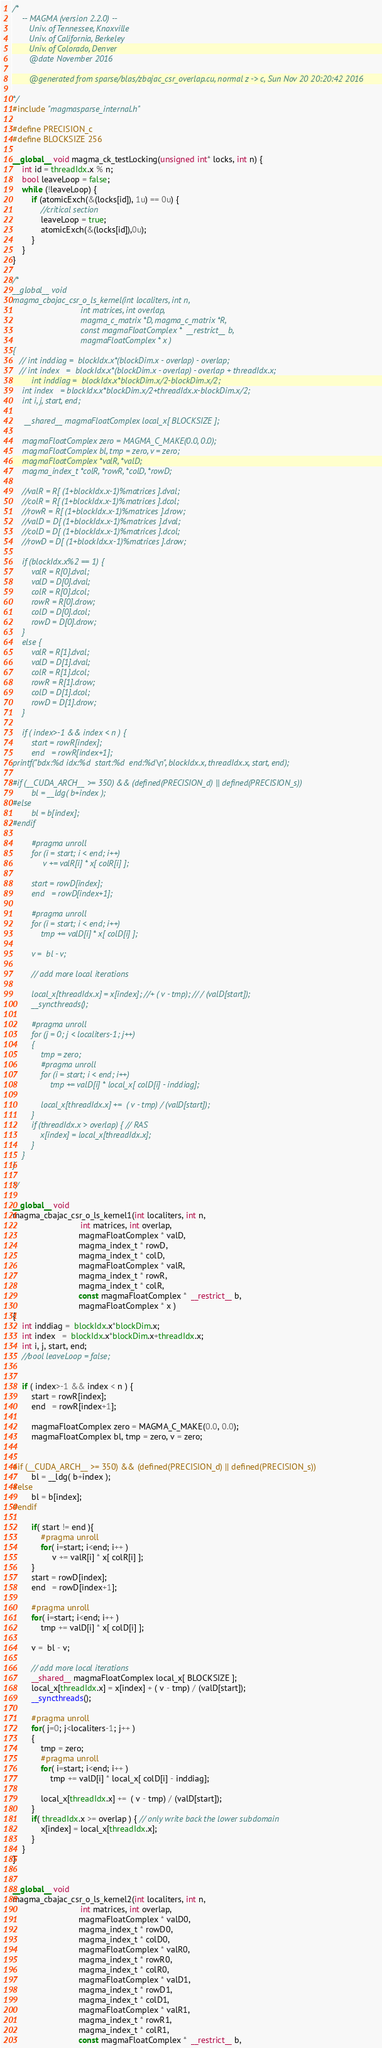<code> <loc_0><loc_0><loc_500><loc_500><_Cuda_>/*
    -- MAGMA (version 2.2.0) --
       Univ. of Tennessee, Knoxville
       Univ. of California, Berkeley
       Univ. of Colorado, Denver
       @date November 2016

       @generated from sparse/blas/zbajac_csr_overlap.cu, normal z -> c, Sun Nov 20 20:20:42 2016

*/
#include "magmasparse_internal.h"

#define PRECISION_c
#define BLOCKSIZE 256

__global__ void magma_ck_testLocking(unsigned int* locks, int n) {
    int id = threadIdx.x % n;
    bool leaveLoop = false;
    while (!leaveLoop) {
        if (atomicExch(&(locks[id]), 1u) == 0u) {
            //critical section
            leaveLoop = true;
            atomicExch(&(locks[id]),0u);
        }
    }
}

/*
__global__ void
magma_cbajac_csr_o_ls_kernel(int localiters, int n, 
                             int matrices, int overlap, 
                             magma_c_matrix *D, magma_c_matrix *R,
                             const magmaFloatComplex *  __restrict__ b,                            
                             magmaFloatComplex * x )
{
   // int inddiag =  blockIdx.x*(blockDim.x - overlap) - overlap;
   // int index   =  blockIdx.x*(blockDim.x - overlap) - overlap + threadIdx.x;
        int inddiag =  blockIdx.x*blockDim.x/2-blockDim.x/2;
    int index   = blockIdx.x*blockDim.x/2+threadIdx.x-blockDim.x/2;
    int i, j, start, end;
    
     __shared__ magmaFloatComplex local_x[ BLOCKSIZE ];
    
    magmaFloatComplex zero = MAGMA_C_MAKE(0.0, 0.0);
    magmaFloatComplex bl, tmp = zero, v = zero; 
    magmaFloatComplex *valR, *valD;
    magma_index_t *colR, *rowR, *colD, *rowD;
    
    //valR = R[ (1+blockIdx.x-1)%matrices ].dval;
    //colR = R[ (1+blockIdx.x-1)%matrices ].dcol;
    //rowR = R[ (1+blockIdx.x-1)%matrices ].drow;
    //valD = D[ (1+blockIdx.x-1)%matrices ].dval;
    //colD = D[ (1+blockIdx.x-1)%matrices ].dcol;
    //rowD = D[ (1+blockIdx.x-1)%matrices ].drow;
    
    if (blockIdx.x%2 == 1) {
        valR = R[0].dval;
        valD = D[0].dval;
        colR = R[0].dcol;
        rowR = R[0].drow;
        colD = D[0].dcol;
        rowD = D[0].drow;
    }
    else {
        valR = R[1].dval;
        valD = D[1].dval;
        colR = R[1].dcol;
        rowR = R[1].drow;
        colD = D[1].dcol;
        rowD = D[1].drow;
    }

    if ( index>-1 && index < n ) {
        start = rowR[index];
        end   = rowR[index+1];
printf("bdx:%d idx:%d  start:%d  end:%d\n", blockIdx.x, threadIdx.x, start, end);

#if (__CUDA_ARCH__ >= 350) && (defined(PRECISION_d) || defined(PRECISION_s))
        bl = __ldg( b+index );
#else
        bl = b[index];
#endif

        #pragma unroll
        for (i = start; i < end; i++)
             v += valR[i] * x[ colR[i] ];
        
        start = rowD[index];
        end   = rowD[index+1];
        
        #pragma unroll
        for (i = start; i < end; i++)
            tmp += valD[i] * x[ colD[i] ];
        
        v =  bl - v;
        
        // add more local iterations            
        
        local_x[threadIdx.x] = x[index]; //+ ( v - tmp); // / (valD[start]);
        __syncthreads();
        
        #pragma unroll
        for (j = 0; j < localiters-1; j++)
        {
            tmp = zero;
            #pragma unroll
            for (i = start; i < end; i++)
                tmp += valD[i] * local_x[ colD[i] - inddiag];
        
            local_x[threadIdx.x] +=  ( v - tmp) / (valD[start]);
        }
        if (threadIdx.x > overlap) { // RAS
            x[index] = local_x[threadIdx.x];
        }
    }
}

*/

__global__ void
magma_cbajac_csr_o_ls_kernel1(int localiters, int n, 
                             int matrices, int overlap, 
                            magmaFloatComplex * valD, 
                            magma_index_t * rowD, 
                            magma_index_t * colD, 
                            magmaFloatComplex * valR, 
                            magma_index_t * rowR,
                            magma_index_t * colR, 
                            const magmaFloatComplex *  __restrict__ b,                            
                            magmaFloatComplex * x )
{
    int inddiag =  blockIdx.x*blockDim.x;
    int index   =  blockIdx.x*blockDim.x+threadIdx.x;
    int i, j, start, end;
    //bool leaveLoop = false;
    

    if ( index>-1 && index < n ) {
        start = rowR[index];
        end   = rowR[index+1];

        magmaFloatComplex zero = MAGMA_C_MAKE(0.0, 0.0);
        magmaFloatComplex bl, tmp = zero, v = zero; 


#if (__CUDA_ARCH__ >= 350) && (defined(PRECISION_d) || defined(PRECISION_s))
        bl = __ldg( b+index );
#else
        bl = b[index];
#endif

        if( start != end ){
            #pragma unroll
            for( i=start; i<end; i++ )
                 v += valR[i] * x[ colR[i] ];
        }
        start = rowD[index];
        end   = rowD[index+1];

        #pragma unroll
        for( i=start; i<end; i++ )
            tmp += valD[i] * x[ colD[i] ];

        v =  bl - v;

        // add more local iterations            
        __shared__ magmaFloatComplex local_x[ BLOCKSIZE ];
        local_x[threadIdx.x] = x[index] + ( v - tmp) / (valD[start]);
        __syncthreads();

        #pragma unroll
        for( j=0; j<localiters-1; j++ )
        {
            tmp = zero;
            #pragma unroll
            for( i=start; i<end; i++ )
                tmp += valD[i] * local_x[ colD[i] - inddiag];
        
            local_x[threadIdx.x] +=  ( v - tmp) / (valD[start]);
        }
        if( threadIdx.x >= overlap ) { // only write back the lower subdomain
            x[index] = local_x[threadIdx.x];
        }
    }
}


__global__ void
magma_cbajac_csr_o_ls_kernel2(int localiters, int n, 
                             int matrices, int overlap, 
                            magmaFloatComplex * valD0, 
                            magma_index_t * rowD0, 
                            magma_index_t * colD0, 
                            magmaFloatComplex * valR0, 
                            magma_index_t * rowR0,
                            magma_index_t * colR0, 
                            magmaFloatComplex * valD1, 
                            magma_index_t * rowD1, 
                            magma_index_t * colD1, 
                            magmaFloatComplex * valR1, 
                            magma_index_t * rowR1,
                            magma_index_t * colR1, 
                            const magmaFloatComplex *  __restrict__ b,                            </code> 